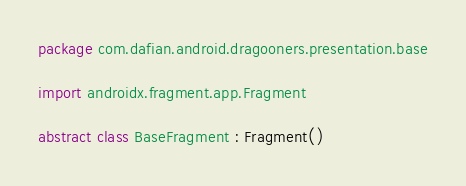<code> <loc_0><loc_0><loc_500><loc_500><_Kotlin_>package com.dafian.android.dragooners.presentation.base

import androidx.fragment.app.Fragment

abstract class BaseFragment : Fragment()</code> 